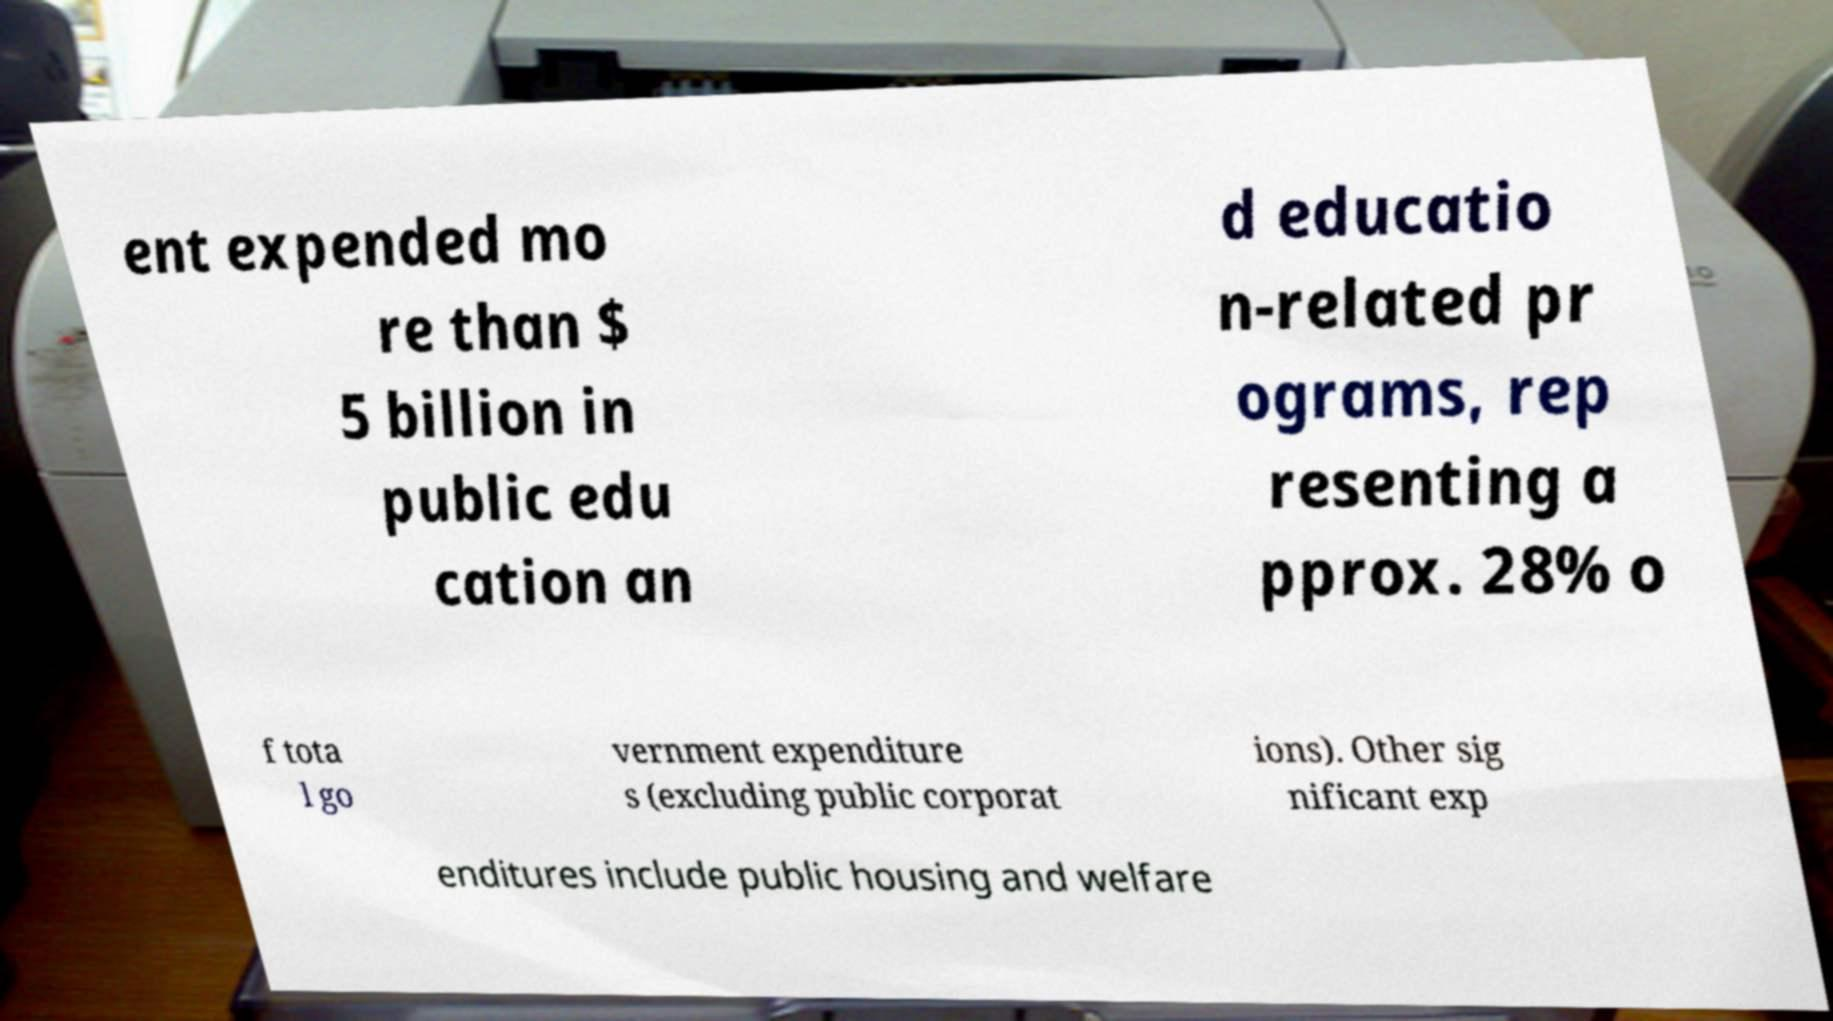What messages or text are displayed in this image? I need them in a readable, typed format. ent expended mo re than $ 5 billion in public edu cation an d educatio n-related pr ograms, rep resenting a pprox. 28% o f tota l go vernment expenditure s (excluding public corporat ions). Other sig nificant exp enditures include public housing and welfare 